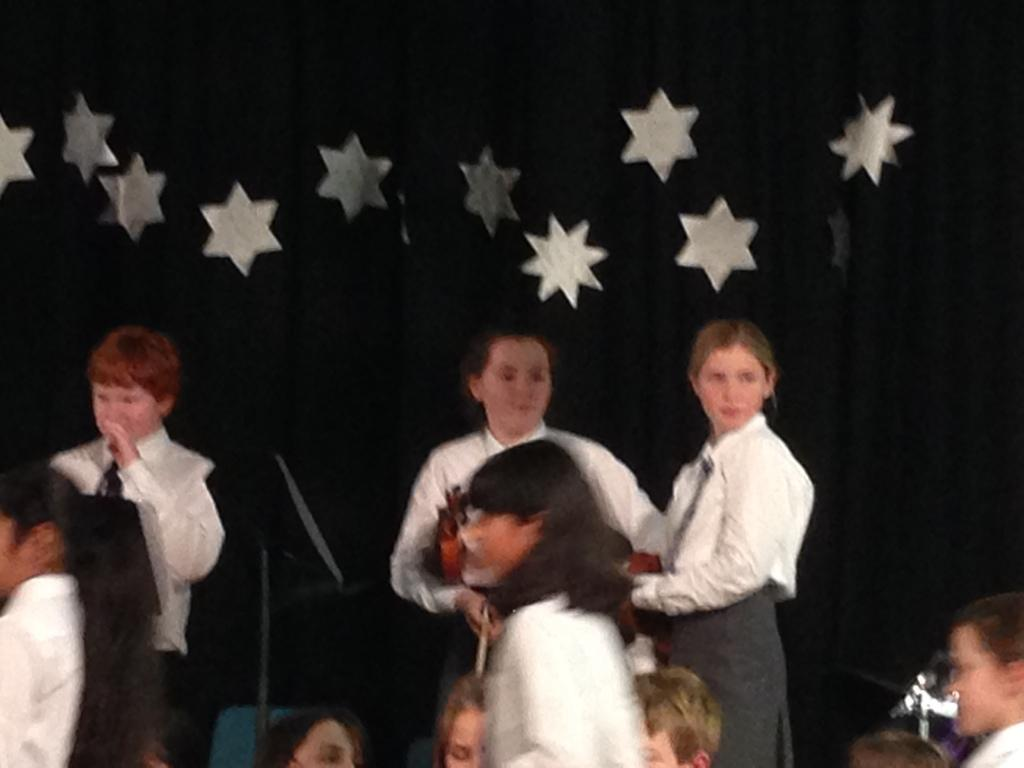Who or what is present in the image? There are people in the image. What are the people wearing on their upper bodies? The people are wearing white shirts. What additional accessory can be seen on the people? The people are wearing ties. What can be seen in the background of the image? There is a black cloth with stars in the background of the image. What type of ship can be seen in the image? There is no ship present in the image. What role does the judge play in the image? There is no judge present in the image. 